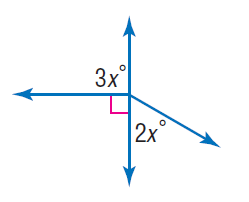Answer the mathemtical geometry problem and directly provide the correct option letter.
Question: Find x.
Choices: A: 30 B: 60 C: 90 D: 120 A 